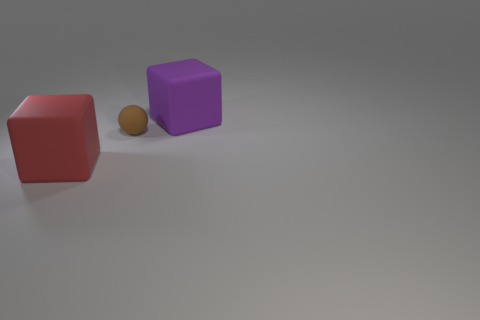Is there anything else that has the same size as the brown sphere?
Offer a terse response. No. How many large things are metallic cubes or rubber spheres?
Your response must be concise. 0. The tiny ball has what color?
Make the answer very short. Brown. There is a large matte block that is to the left of the large purple rubber object; are there any rubber cubes that are to the right of it?
Make the answer very short. Yes. Are there fewer objects that are on the right side of the brown rubber object than big blue objects?
Provide a succinct answer. No. The sphere that is made of the same material as the red block is what color?
Make the answer very short. Brown. Are there fewer cubes behind the big purple rubber cube than rubber cubes in front of the tiny brown ball?
Your answer should be compact. Yes. Is there another sphere that has the same material as the tiny brown ball?
Give a very brief answer. No. There is a block to the left of the thing that is behind the small matte object; what is its size?
Make the answer very short. Large. Are there more red things than large gray rubber cubes?
Ensure brevity in your answer.  Yes. 